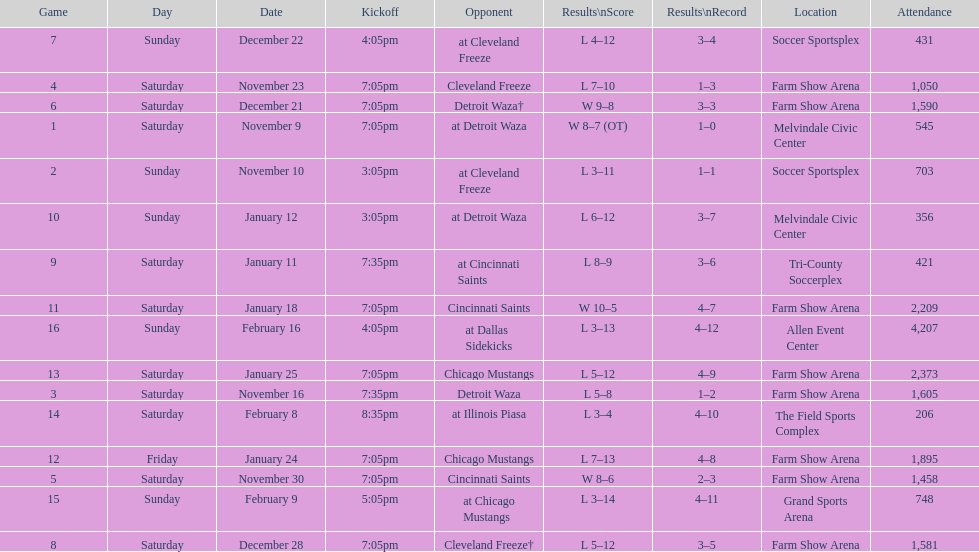Which opponent is listed first in the table? Detroit Waza. 